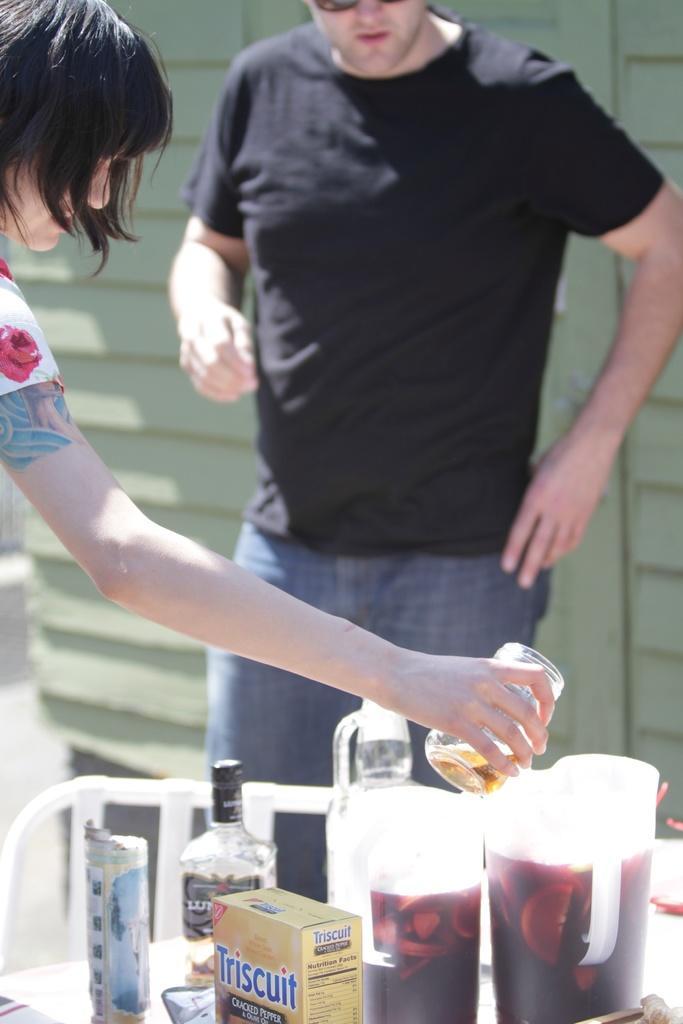Describe this image in one or two sentences. In this picture we can see two persons. She is holding a glass with her hand. This is table. On the table there are jars, bottles, and boxes. On the background there is a wall. 